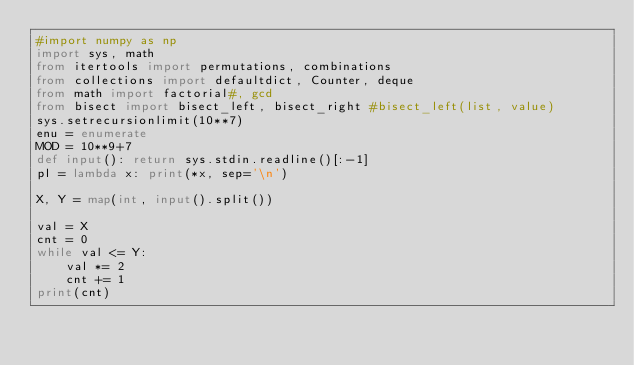<code> <loc_0><loc_0><loc_500><loc_500><_Python_>#import numpy as np
import sys, math
from itertools import permutations, combinations
from collections import defaultdict, Counter, deque
from math import factorial#, gcd
from bisect import bisect_left, bisect_right #bisect_left(list, value)
sys.setrecursionlimit(10**7)
enu = enumerate
MOD = 10**9+7
def input(): return sys.stdin.readline()[:-1]
pl = lambda x: print(*x, sep='\n')

X, Y = map(int, input().split())

val = X
cnt = 0
while val <= Y:
    val *= 2
    cnt += 1
print(cnt)</code> 